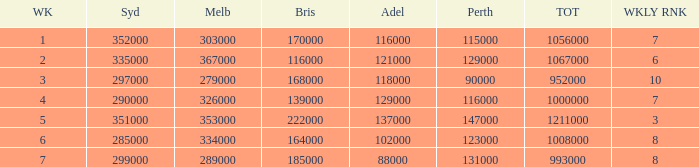How many Adelaide viewers were there in Week 5? 137000.0. 